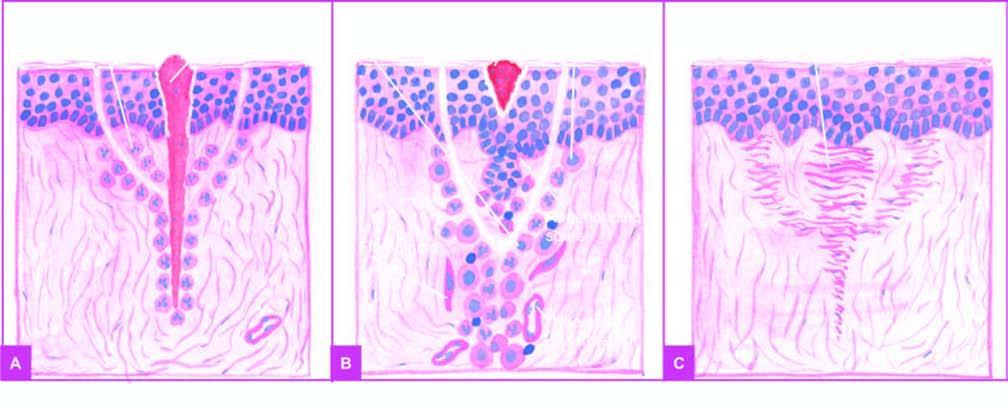what at around 7th day results in scar tissue at the sites of incision and suture track?
Answer the question using a single word or phrase. Removal of suture 